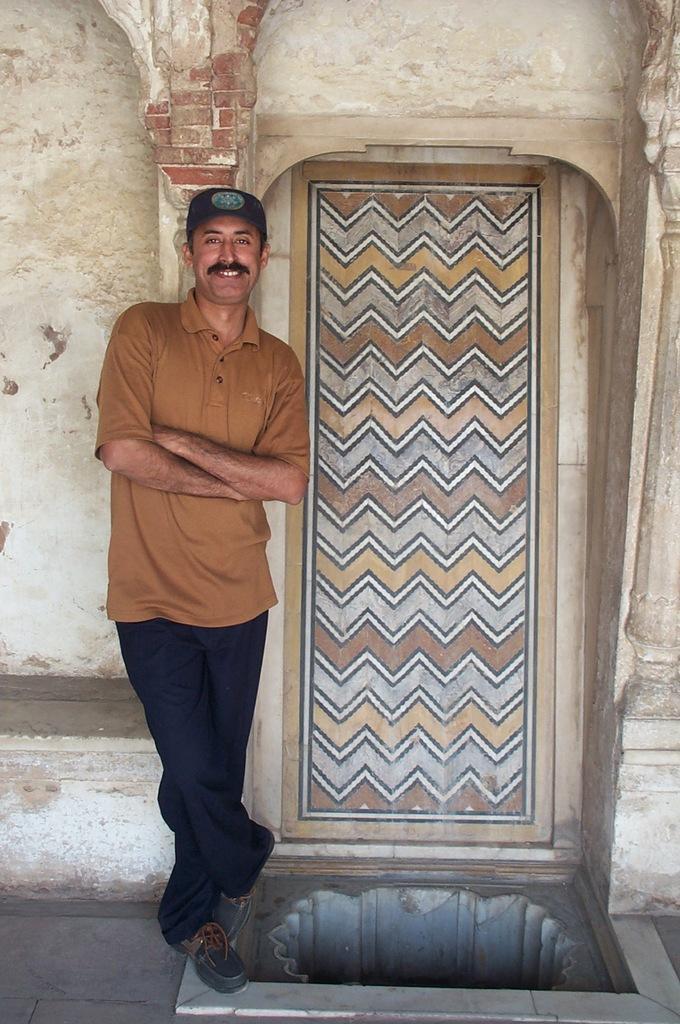Can you describe this image briefly? In this picture, I can see a old building and a door and a person standing folding his hands. 